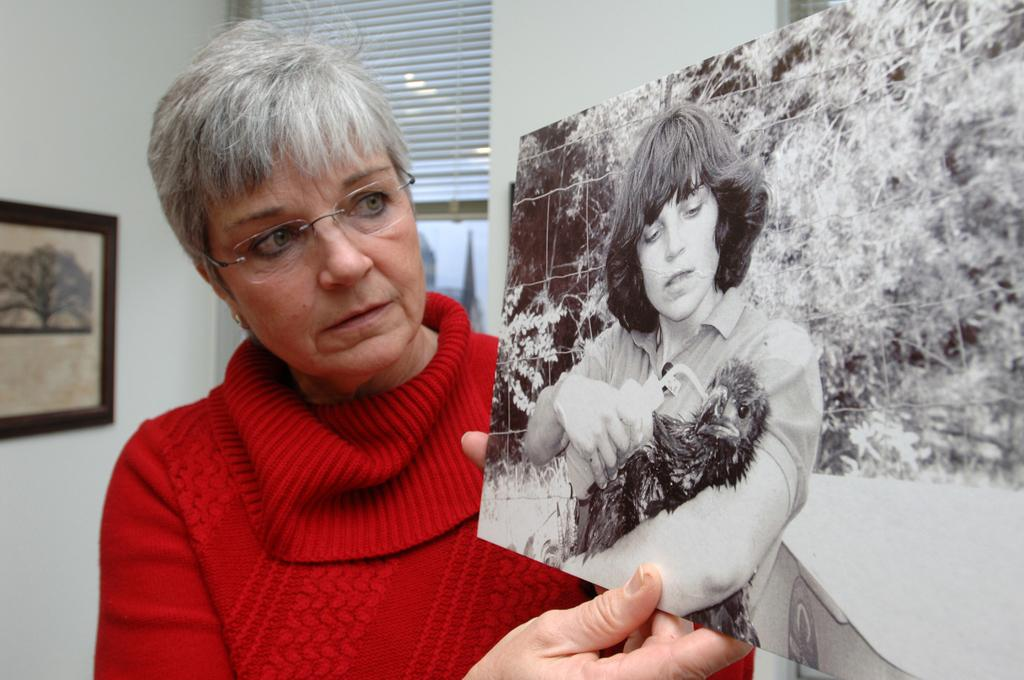What is the person in the image holding? The person is holding a photograph. What can be seen in the background of the image? There is a wall, a photo frame, and other objects visible in the background of the image. What might be the purpose of the photo frame in the image? The photo frame in the background might be used to display a photograph or artwork. What type of bear can be seen sitting on the person's shoulder in the image? There is no bear present in the image; the person is holding a photograph. What type of beef dish is being prepared in the background of the image? There is no beef dish or any food preparation visible in the image. 